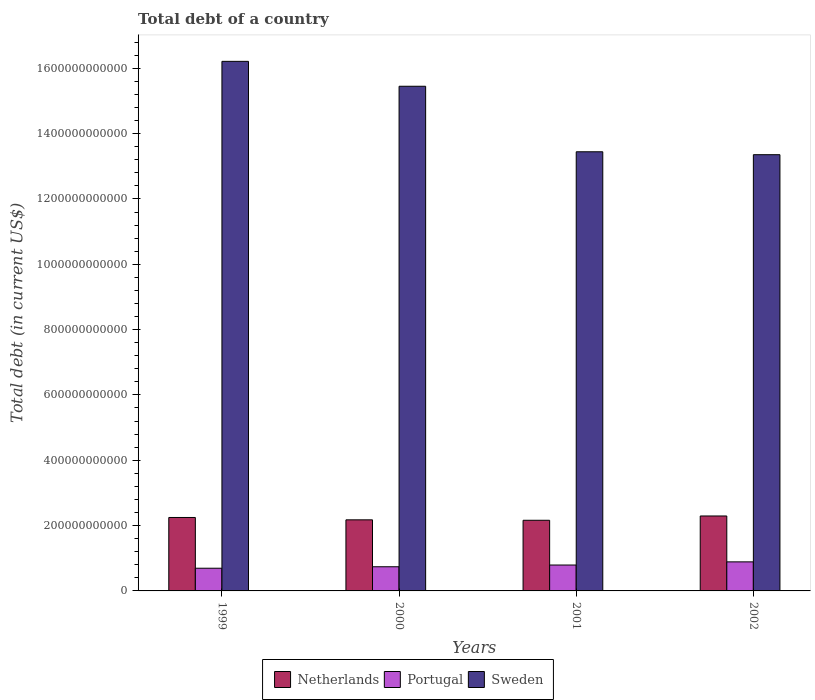How many different coloured bars are there?
Give a very brief answer. 3. How many groups of bars are there?
Offer a very short reply. 4. How many bars are there on the 1st tick from the left?
Your answer should be compact. 3. How many bars are there on the 2nd tick from the right?
Offer a terse response. 3. What is the debt in Sweden in 2001?
Provide a short and direct response. 1.34e+12. Across all years, what is the maximum debt in Netherlands?
Your answer should be compact. 2.29e+11. Across all years, what is the minimum debt in Netherlands?
Provide a short and direct response. 2.16e+11. In which year was the debt in Portugal maximum?
Your answer should be very brief. 2002. What is the total debt in Portugal in the graph?
Give a very brief answer. 3.12e+11. What is the difference between the debt in Sweden in 1999 and that in 2001?
Provide a short and direct response. 2.77e+11. What is the difference between the debt in Sweden in 2002 and the debt in Netherlands in 1999?
Provide a short and direct response. 1.11e+12. What is the average debt in Portugal per year?
Give a very brief answer. 7.79e+1. In the year 1999, what is the difference between the debt in Netherlands and debt in Portugal?
Keep it short and to the point. 1.55e+11. In how many years, is the debt in Netherlands greater than 1080000000000 US$?
Ensure brevity in your answer.  0. What is the ratio of the debt in Sweden in 2000 to that in 2002?
Offer a terse response. 1.16. Is the debt in Netherlands in 1999 less than that in 2001?
Give a very brief answer. No. What is the difference between the highest and the second highest debt in Portugal?
Offer a terse response. 9.68e+09. What is the difference between the highest and the lowest debt in Sweden?
Make the answer very short. 2.86e+11. What does the 3rd bar from the left in 2001 represents?
Your answer should be compact. Sweden. How many years are there in the graph?
Your answer should be very brief. 4. What is the difference between two consecutive major ticks on the Y-axis?
Your answer should be very brief. 2.00e+11. Are the values on the major ticks of Y-axis written in scientific E-notation?
Your answer should be compact. No. Does the graph contain any zero values?
Offer a terse response. No. How many legend labels are there?
Provide a succinct answer. 3. How are the legend labels stacked?
Your answer should be compact. Horizontal. What is the title of the graph?
Provide a short and direct response. Total debt of a country. What is the label or title of the Y-axis?
Ensure brevity in your answer.  Total debt (in current US$). What is the Total debt (in current US$) of Netherlands in 1999?
Provide a short and direct response. 2.25e+11. What is the Total debt (in current US$) in Portugal in 1999?
Your response must be concise. 6.95e+1. What is the Total debt (in current US$) in Sweden in 1999?
Your answer should be compact. 1.62e+12. What is the Total debt (in current US$) in Netherlands in 2000?
Make the answer very short. 2.18e+11. What is the Total debt (in current US$) of Portugal in 2000?
Ensure brevity in your answer.  7.40e+1. What is the Total debt (in current US$) of Sweden in 2000?
Make the answer very short. 1.54e+12. What is the Total debt (in current US$) of Netherlands in 2001?
Your answer should be compact. 2.16e+11. What is the Total debt (in current US$) in Portugal in 2001?
Offer a very short reply. 7.93e+1. What is the Total debt (in current US$) of Sweden in 2001?
Keep it short and to the point. 1.34e+12. What is the Total debt (in current US$) in Netherlands in 2002?
Make the answer very short. 2.29e+11. What is the Total debt (in current US$) of Portugal in 2002?
Provide a short and direct response. 8.90e+1. What is the Total debt (in current US$) in Sweden in 2002?
Offer a terse response. 1.34e+12. Across all years, what is the maximum Total debt (in current US$) of Netherlands?
Offer a terse response. 2.29e+11. Across all years, what is the maximum Total debt (in current US$) of Portugal?
Give a very brief answer. 8.90e+1. Across all years, what is the maximum Total debt (in current US$) in Sweden?
Offer a terse response. 1.62e+12. Across all years, what is the minimum Total debt (in current US$) of Netherlands?
Ensure brevity in your answer.  2.16e+11. Across all years, what is the minimum Total debt (in current US$) in Portugal?
Offer a very short reply. 6.95e+1. Across all years, what is the minimum Total debt (in current US$) of Sweden?
Offer a terse response. 1.34e+12. What is the total Total debt (in current US$) of Netherlands in the graph?
Offer a terse response. 8.88e+11. What is the total Total debt (in current US$) of Portugal in the graph?
Give a very brief answer. 3.12e+11. What is the total Total debt (in current US$) of Sweden in the graph?
Your response must be concise. 5.85e+12. What is the difference between the Total debt (in current US$) in Netherlands in 1999 and that in 2000?
Offer a very short reply. 7.24e+09. What is the difference between the Total debt (in current US$) of Portugal in 1999 and that in 2000?
Your answer should be very brief. -4.50e+09. What is the difference between the Total debt (in current US$) of Sweden in 1999 and that in 2000?
Your response must be concise. 7.62e+1. What is the difference between the Total debt (in current US$) of Netherlands in 1999 and that in 2001?
Your answer should be very brief. 8.60e+09. What is the difference between the Total debt (in current US$) of Portugal in 1999 and that in 2001?
Offer a terse response. -9.81e+09. What is the difference between the Total debt (in current US$) of Sweden in 1999 and that in 2001?
Offer a terse response. 2.77e+11. What is the difference between the Total debt (in current US$) of Netherlands in 1999 and that in 2002?
Provide a succinct answer. -4.58e+09. What is the difference between the Total debt (in current US$) of Portugal in 1999 and that in 2002?
Offer a very short reply. -1.95e+1. What is the difference between the Total debt (in current US$) of Sweden in 1999 and that in 2002?
Provide a short and direct response. 2.86e+11. What is the difference between the Total debt (in current US$) of Netherlands in 2000 and that in 2001?
Give a very brief answer. 1.36e+09. What is the difference between the Total debt (in current US$) of Portugal in 2000 and that in 2001?
Your answer should be very brief. -5.31e+09. What is the difference between the Total debt (in current US$) in Sweden in 2000 and that in 2001?
Keep it short and to the point. 2.01e+11. What is the difference between the Total debt (in current US$) in Netherlands in 2000 and that in 2002?
Your answer should be very brief. -1.18e+1. What is the difference between the Total debt (in current US$) of Portugal in 2000 and that in 2002?
Your response must be concise. -1.50e+1. What is the difference between the Total debt (in current US$) of Sweden in 2000 and that in 2002?
Ensure brevity in your answer.  2.10e+11. What is the difference between the Total debt (in current US$) of Netherlands in 2001 and that in 2002?
Make the answer very short. -1.32e+1. What is the difference between the Total debt (in current US$) in Portugal in 2001 and that in 2002?
Offer a very short reply. -9.68e+09. What is the difference between the Total debt (in current US$) of Sweden in 2001 and that in 2002?
Your answer should be compact. 8.93e+09. What is the difference between the Total debt (in current US$) of Netherlands in 1999 and the Total debt (in current US$) of Portugal in 2000?
Your answer should be very brief. 1.51e+11. What is the difference between the Total debt (in current US$) in Netherlands in 1999 and the Total debt (in current US$) in Sweden in 2000?
Give a very brief answer. -1.32e+12. What is the difference between the Total debt (in current US$) in Portugal in 1999 and the Total debt (in current US$) in Sweden in 2000?
Offer a very short reply. -1.48e+12. What is the difference between the Total debt (in current US$) of Netherlands in 1999 and the Total debt (in current US$) of Portugal in 2001?
Provide a succinct answer. 1.46e+11. What is the difference between the Total debt (in current US$) of Netherlands in 1999 and the Total debt (in current US$) of Sweden in 2001?
Provide a short and direct response. -1.12e+12. What is the difference between the Total debt (in current US$) of Portugal in 1999 and the Total debt (in current US$) of Sweden in 2001?
Give a very brief answer. -1.27e+12. What is the difference between the Total debt (in current US$) in Netherlands in 1999 and the Total debt (in current US$) in Portugal in 2002?
Make the answer very short. 1.36e+11. What is the difference between the Total debt (in current US$) in Netherlands in 1999 and the Total debt (in current US$) in Sweden in 2002?
Your answer should be compact. -1.11e+12. What is the difference between the Total debt (in current US$) in Portugal in 1999 and the Total debt (in current US$) in Sweden in 2002?
Offer a very short reply. -1.27e+12. What is the difference between the Total debt (in current US$) of Netherlands in 2000 and the Total debt (in current US$) of Portugal in 2001?
Give a very brief answer. 1.38e+11. What is the difference between the Total debt (in current US$) in Netherlands in 2000 and the Total debt (in current US$) in Sweden in 2001?
Your answer should be compact. -1.13e+12. What is the difference between the Total debt (in current US$) of Portugal in 2000 and the Total debt (in current US$) of Sweden in 2001?
Your answer should be compact. -1.27e+12. What is the difference between the Total debt (in current US$) of Netherlands in 2000 and the Total debt (in current US$) of Portugal in 2002?
Provide a succinct answer. 1.29e+11. What is the difference between the Total debt (in current US$) of Netherlands in 2000 and the Total debt (in current US$) of Sweden in 2002?
Your answer should be very brief. -1.12e+12. What is the difference between the Total debt (in current US$) in Portugal in 2000 and the Total debt (in current US$) in Sweden in 2002?
Your response must be concise. -1.26e+12. What is the difference between the Total debt (in current US$) in Netherlands in 2001 and the Total debt (in current US$) in Portugal in 2002?
Your response must be concise. 1.27e+11. What is the difference between the Total debt (in current US$) of Netherlands in 2001 and the Total debt (in current US$) of Sweden in 2002?
Offer a terse response. -1.12e+12. What is the difference between the Total debt (in current US$) of Portugal in 2001 and the Total debt (in current US$) of Sweden in 2002?
Your response must be concise. -1.26e+12. What is the average Total debt (in current US$) of Netherlands per year?
Offer a terse response. 2.22e+11. What is the average Total debt (in current US$) in Portugal per year?
Ensure brevity in your answer.  7.79e+1. What is the average Total debt (in current US$) of Sweden per year?
Ensure brevity in your answer.  1.46e+12. In the year 1999, what is the difference between the Total debt (in current US$) of Netherlands and Total debt (in current US$) of Portugal?
Provide a succinct answer. 1.55e+11. In the year 1999, what is the difference between the Total debt (in current US$) of Netherlands and Total debt (in current US$) of Sweden?
Provide a succinct answer. -1.40e+12. In the year 1999, what is the difference between the Total debt (in current US$) of Portugal and Total debt (in current US$) of Sweden?
Provide a short and direct response. -1.55e+12. In the year 2000, what is the difference between the Total debt (in current US$) in Netherlands and Total debt (in current US$) in Portugal?
Your answer should be compact. 1.44e+11. In the year 2000, what is the difference between the Total debt (in current US$) in Netherlands and Total debt (in current US$) in Sweden?
Your response must be concise. -1.33e+12. In the year 2000, what is the difference between the Total debt (in current US$) in Portugal and Total debt (in current US$) in Sweden?
Provide a succinct answer. -1.47e+12. In the year 2001, what is the difference between the Total debt (in current US$) of Netherlands and Total debt (in current US$) of Portugal?
Your answer should be compact. 1.37e+11. In the year 2001, what is the difference between the Total debt (in current US$) of Netherlands and Total debt (in current US$) of Sweden?
Your response must be concise. -1.13e+12. In the year 2001, what is the difference between the Total debt (in current US$) of Portugal and Total debt (in current US$) of Sweden?
Provide a short and direct response. -1.27e+12. In the year 2002, what is the difference between the Total debt (in current US$) of Netherlands and Total debt (in current US$) of Portugal?
Provide a short and direct response. 1.40e+11. In the year 2002, what is the difference between the Total debt (in current US$) in Netherlands and Total debt (in current US$) in Sweden?
Provide a short and direct response. -1.11e+12. In the year 2002, what is the difference between the Total debt (in current US$) of Portugal and Total debt (in current US$) of Sweden?
Give a very brief answer. -1.25e+12. What is the ratio of the Total debt (in current US$) in Netherlands in 1999 to that in 2000?
Make the answer very short. 1.03. What is the ratio of the Total debt (in current US$) in Portugal in 1999 to that in 2000?
Your response must be concise. 0.94. What is the ratio of the Total debt (in current US$) in Sweden in 1999 to that in 2000?
Provide a short and direct response. 1.05. What is the ratio of the Total debt (in current US$) in Netherlands in 1999 to that in 2001?
Your response must be concise. 1.04. What is the ratio of the Total debt (in current US$) in Portugal in 1999 to that in 2001?
Provide a short and direct response. 0.88. What is the ratio of the Total debt (in current US$) of Sweden in 1999 to that in 2001?
Keep it short and to the point. 1.21. What is the ratio of the Total debt (in current US$) in Netherlands in 1999 to that in 2002?
Provide a short and direct response. 0.98. What is the ratio of the Total debt (in current US$) in Portugal in 1999 to that in 2002?
Make the answer very short. 0.78. What is the ratio of the Total debt (in current US$) of Sweden in 1999 to that in 2002?
Provide a short and direct response. 1.21. What is the ratio of the Total debt (in current US$) in Netherlands in 2000 to that in 2001?
Give a very brief answer. 1.01. What is the ratio of the Total debt (in current US$) of Portugal in 2000 to that in 2001?
Provide a succinct answer. 0.93. What is the ratio of the Total debt (in current US$) of Sweden in 2000 to that in 2001?
Provide a short and direct response. 1.15. What is the ratio of the Total debt (in current US$) of Netherlands in 2000 to that in 2002?
Your answer should be very brief. 0.95. What is the ratio of the Total debt (in current US$) in Portugal in 2000 to that in 2002?
Offer a very short reply. 0.83. What is the ratio of the Total debt (in current US$) in Sweden in 2000 to that in 2002?
Your response must be concise. 1.16. What is the ratio of the Total debt (in current US$) in Netherlands in 2001 to that in 2002?
Give a very brief answer. 0.94. What is the ratio of the Total debt (in current US$) of Portugal in 2001 to that in 2002?
Give a very brief answer. 0.89. What is the difference between the highest and the second highest Total debt (in current US$) in Netherlands?
Make the answer very short. 4.58e+09. What is the difference between the highest and the second highest Total debt (in current US$) in Portugal?
Give a very brief answer. 9.68e+09. What is the difference between the highest and the second highest Total debt (in current US$) in Sweden?
Your answer should be very brief. 7.62e+1. What is the difference between the highest and the lowest Total debt (in current US$) of Netherlands?
Your response must be concise. 1.32e+1. What is the difference between the highest and the lowest Total debt (in current US$) in Portugal?
Your response must be concise. 1.95e+1. What is the difference between the highest and the lowest Total debt (in current US$) of Sweden?
Your answer should be compact. 2.86e+11. 